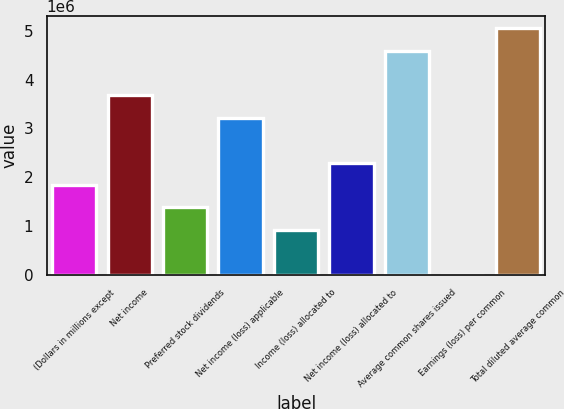<chart> <loc_0><loc_0><loc_500><loc_500><bar_chart><fcel>(Dollars in millions except<fcel>Net income<fcel>Preferred stock dividends<fcel>Net income (loss) applicable<fcel>Income (loss) allocated to<fcel>Net income (loss) allocated to<fcel>Average common shares issued<fcel>Earnings (loss) per common<fcel>Total diluted average common<nl><fcel>1.83857e+06<fcel>3.67714e+06<fcel>1.37893e+06<fcel>3.2175e+06<fcel>919286<fcel>2.29821e+06<fcel>4.59208e+06<fcel>0.54<fcel>5.05173e+06<nl></chart> 